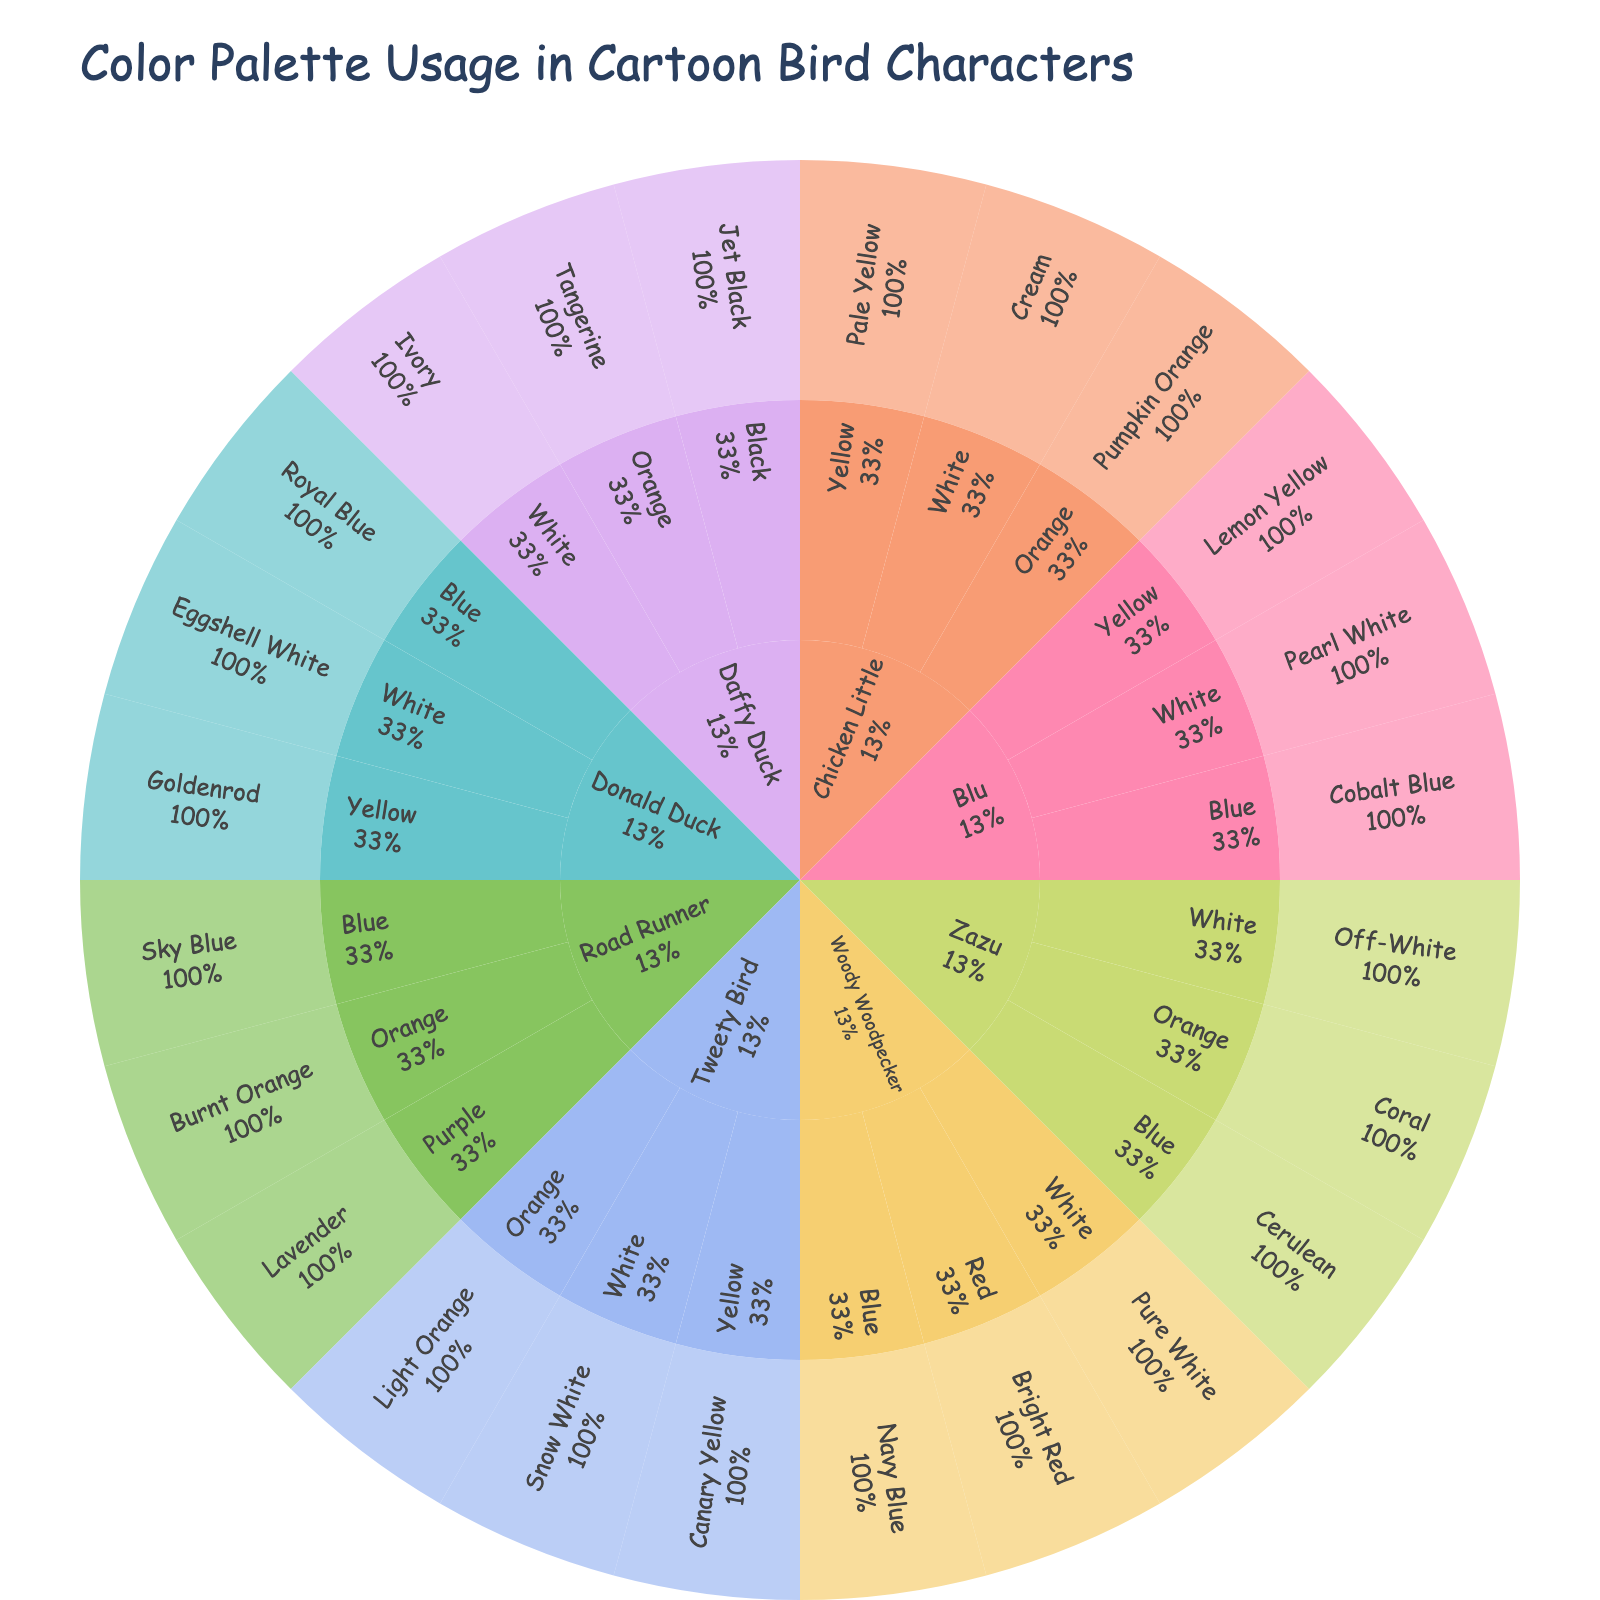What's the title of the figure? The title is the most prominent text at the top of the plot and typically provides an overview of the visualized data.
Answer: Color Palette Usage in Cartoon Bird Characters How many unique characters are represented in the plot? Each main segment of the Sunburst Plot corresponds to a different cartoon bird character. Count these segments.
Answer: 7 Which character has the highest number of color shades? Observe the Sunburst plot to determine which character has the largest number of child segments representing different shades.
Answer: Tweety Bird What is the percentage representation of shades of the color "Blue" in Woody Woodpecker? Find the Blue segment under Woody Woodpecker and look at the percentage it represents among Woody's colors.
Answer: 33.3% Which shade of the color "Orange" is associated with Road Runner? Locate the Orange segment under Road Runner and identify its associated shade.
Answer: Burnt Orange How do the color palettes of Woody Woodpecker and Donald Duck compare in terms of diversity? Compare the number of different colors and shades within the segments of Woody Woodpecker and Donald Duck to determine which character has a more diverse palette.
Answer: Woody Woodpecker has a more diverse palette What proportion of Daffy Duck's colors are shades of white? Look at Daffy Duck's segment and identify the white shade(s), then determine its/their percentage contribution to Daffy Duck's overall palette.
Answer: 33.3% Which character's color palette includes the shade "Pearl White"? Navigate through the shades of white for each character until "Pearl White" is found.
Answer: Blu What is the common color present in Road Runner's and Chicken Little's palettes? Identify which shades are common by examining the color segments under both characters.
Answer: Orange How many characters include shades of Yellow in their palette? Examine the color segments for each character to count the ones that have any shade of yellow.
Answer: 4 